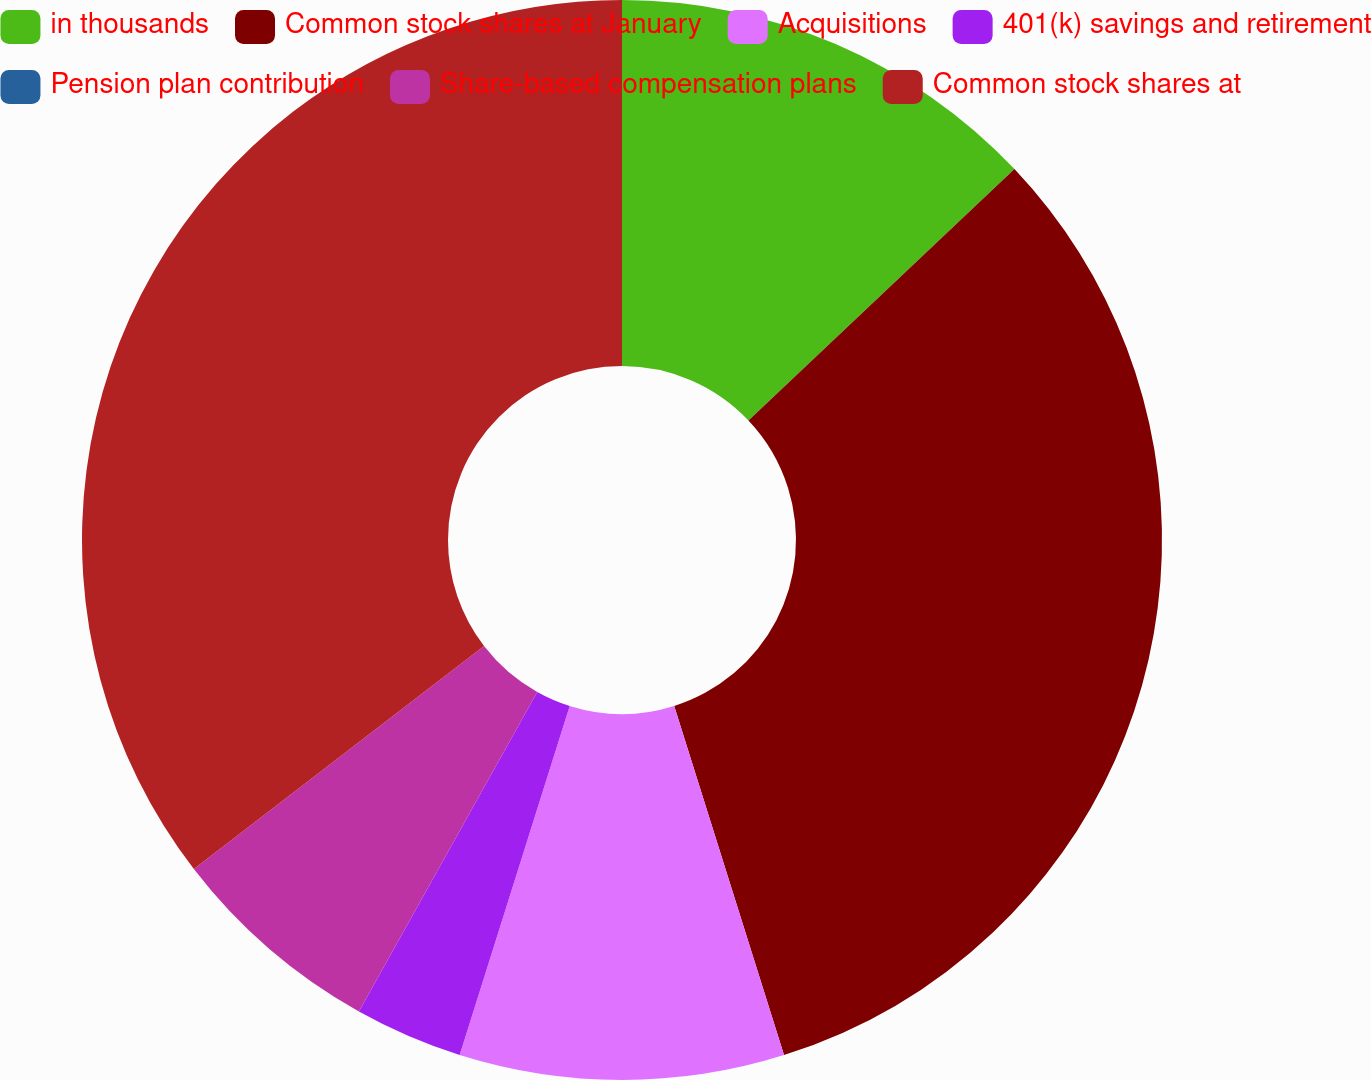Convert chart to OTSL. <chart><loc_0><loc_0><loc_500><loc_500><pie_chart><fcel>in thousands<fcel>Common stock shares at January<fcel>Acquisitions<fcel>401(k) savings and retirement<fcel>Pension plan contribution<fcel>Share-based compensation plans<fcel>Common stock shares at<nl><fcel>12.95%<fcel>32.2%<fcel>9.71%<fcel>3.24%<fcel>0.0%<fcel>6.47%<fcel>35.43%<nl></chart> 